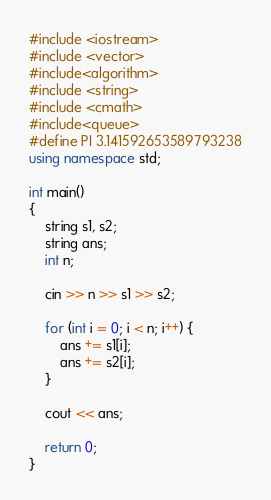<code> <loc_0><loc_0><loc_500><loc_500><_C++_>#include <iostream>
#include <vector>
#include<algorithm>
#include <string>
#include <cmath>
#include<queue>
#define PI 3.141592653589793238
using namespace std;

int main()
{
	string s1, s2;
	string ans;
	int n;

	cin >> n >> s1 >> s2;

	for (int i = 0; i < n; i++) {
		ans += s1[i];
		ans += s2[i];
	}

	cout << ans;

	return 0;
}</code> 